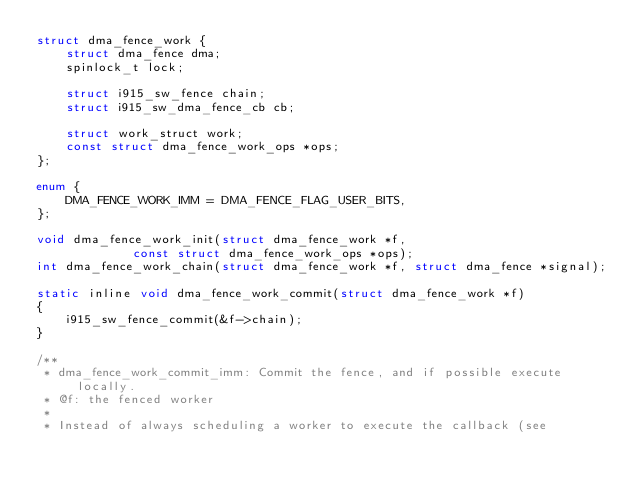<code> <loc_0><loc_0><loc_500><loc_500><_C_>struct dma_fence_work {
	struct dma_fence dma;
	spinlock_t lock;

	struct i915_sw_fence chain;
	struct i915_sw_dma_fence_cb cb;

	struct work_struct work;
	const struct dma_fence_work_ops *ops;
};

enum {
	DMA_FENCE_WORK_IMM = DMA_FENCE_FLAG_USER_BITS,
};

void dma_fence_work_init(struct dma_fence_work *f,
			 const struct dma_fence_work_ops *ops);
int dma_fence_work_chain(struct dma_fence_work *f, struct dma_fence *signal);

static inline void dma_fence_work_commit(struct dma_fence_work *f)
{
	i915_sw_fence_commit(&f->chain);
}

/**
 * dma_fence_work_commit_imm: Commit the fence, and if possible execute locally.
 * @f: the fenced worker
 *
 * Instead of always scheduling a worker to execute the callback (see</code> 